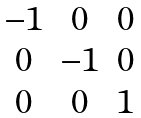<formula> <loc_0><loc_0><loc_500><loc_500>\begin{matrix} - 1 & 0 & 0 \\ 0 & - 1 & 0 \\ 0 & 0 & 1 \end{matrix}</formula> 